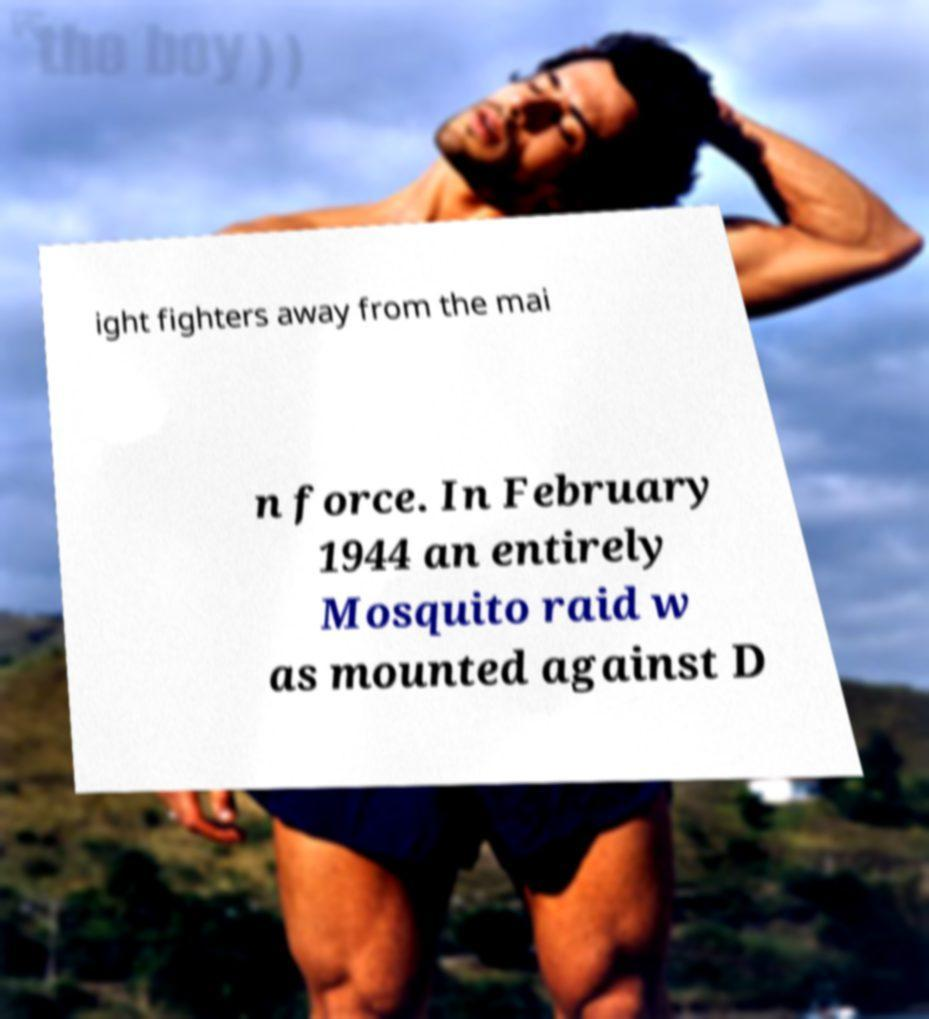Please identify and transcribe the text found in this image. ight fighters away from the mai n force. In February 1944 an entirely Mosquito raid w as mounted against D 